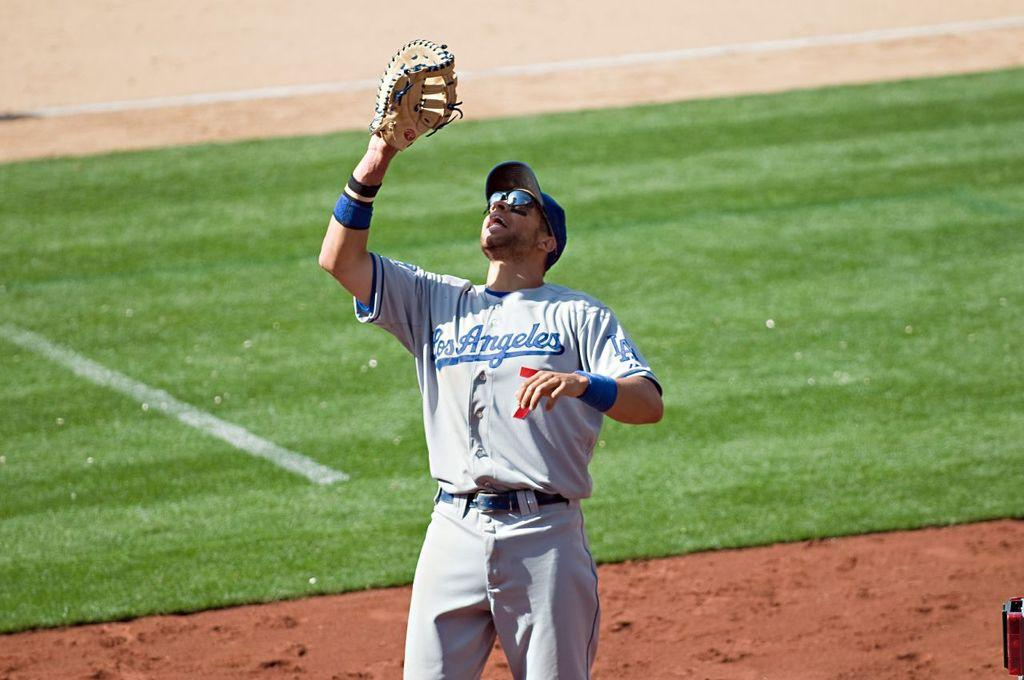<image>
Share a concise interpretation of the image provided. A baseball player wearing a los angeles uniform is holding up a catchers mitt. 